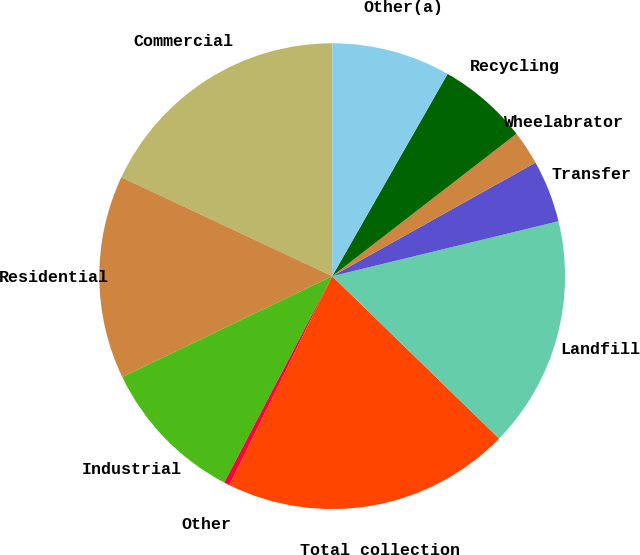<chart> <loc_0><loc_0><loc_500><loc_500><pie_chart><fcel>Commercial<fcel>Residential<fcel>Industrial<fcel>Other<fcel>Total collection<fcel>Landfill<fcel>Transfer<fcel>Wheelabrator<fcel>Recycling<fcel>Other(a)<nl><fcel>18.03%<fcel>14.11%<fcel>10.2%<fcel>0.4%<fcel>19.99%<fcel>16.07%<fcel>4.32%<fcel>2.36%<fcel>6.28%<fcel>8.24%<nl></chart> 